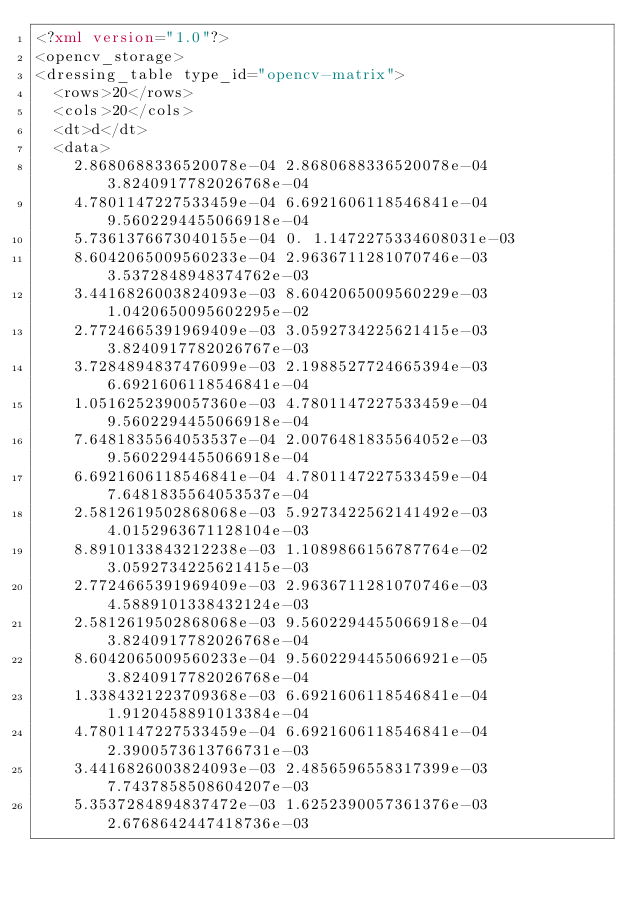<code> <loc_0><loc_0><loc_500><loc_500><_XML_><?xml version="1.0"?>
<opencv_storage>
<dressing_table type_id="opencv-matrix">
  <rows>20</rows>
  <cols>20</cols>
  <dt>d</dt>
  <data>
    2.8680688336520078e-04 2.8680688336520078e-04 3.8240917782026768e-04
    4.7801147227533459e-04 6.6921606118546841e-04 9.5602294455066918e-04
    5.7361376673040155e-04 0. 1.1472275334608031e-03
    8.6042065009560233e-04 2.9636711281070746e-03 3.5372848948374762e-03
    3.4416826003824093e-03 8.6042065009560229e-03 1.0420650095602295e-02
    2.7724665391969409e-03 3.0592734225621415e-03 3.8240917782026767e-03
    3.7284894837476099e-03 2.1988527724665394e-03 6.6921606118546841e-04
    1.0516252390057360e-03 4.7801147227533459e-04 9.5602294455066918e-04
    7.6481835564053537e-04 2.0076481835564052e-03 9.5602294455066918e-04
    6.6921606118546841e-04 4.7801147227533459e-04 7.6481835564053537e-04
    2.5812619502868068e-03 5.9273422562141492e-03 4.0152963671128104e-03
    8.8910133843212238e-03 1.1089866156787764e-02 3.0592734225621415e-03
    2.7724665391969409e-03 2.9636711281070746e-03 4.5889101338432124e-03
    2.5812619502868068e-03 9.5602294455066918e-04 3.8240917782026768e-04
    8.6042065009560233e-04 9.5602294455066921e-05 3.8240917782026768e-04
    1.3384321223709368e-03 6.6921606118546841e-04 1.9120458891013384e-04
    4.7801147227533459e-04 6.6921606118546841e-04 2.3900573613766731e-03
    3.4416826003824093e-03 2.4856596558317399e-03 7.7437858508604207e-03
    5.3537284894837472e-03 1.6252390057361376e-03 2.6768642447418736e-03</code> 